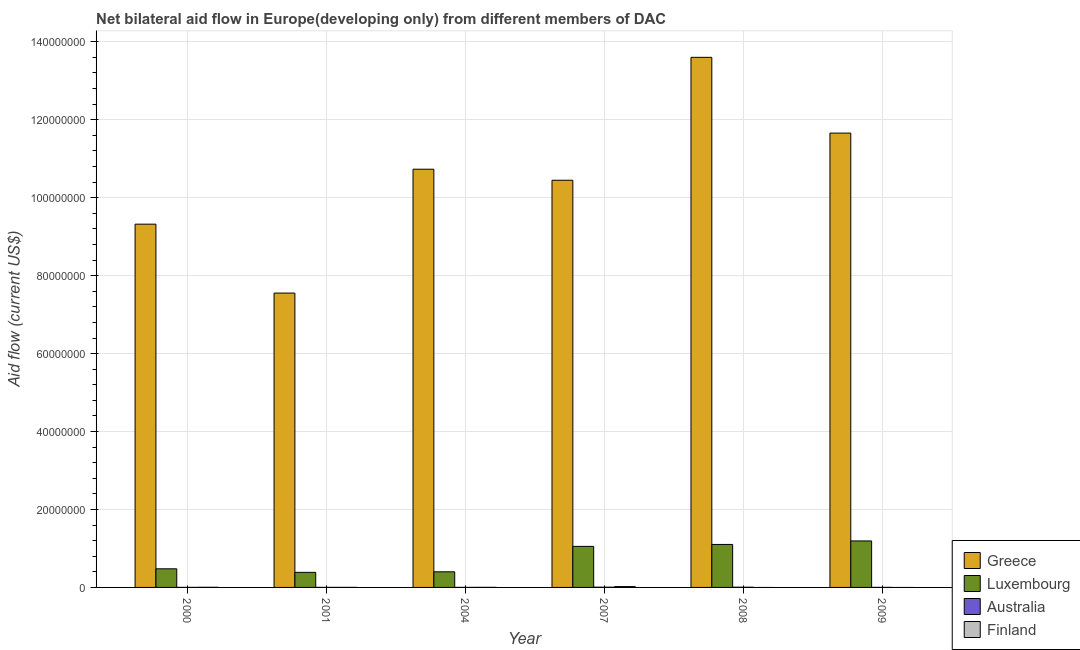How many groups of bars are there?
Make the answer very short. 6. Are the number of bars per tick equal to the number of legend labels?
Make the answer very short. No. How many bars are there on the 2nd tick from the left?
Give a very brief answer. 4. In how many cases, is the number of bars for a given year not equal to the number of legend labels?
Your answer should be very brief. 2. What is the amount of aid given by greece in 2004?
Give a very brief answer. 1.07e+08. Across all years, what is the maximum amount of aid given by luxembourg?
Provide a short and direct response. 1.19e+07. Across all years, what is the minimum amount of aid given by australia?
Make the answer very short. 10000. What is the total amount of aid given by finland in the graph?
Offer a terse response. 2.70e+05. What is the difference between the amount of aid given by australia in 2000 and that in 2008?
Your answer should be very brief. -4.00e+04. What is the difference between the amount of aid given by finland in 2008 and the amount of aid given by australia in 2000?
Ensure brevity in your answer.  -3.00e+04. What is the average amount of aid given by luxembourg per year?
Provide a succinct answer. 7.69e+06. In the year 2001, what is the difference between the amount of aid given by luxembourg and amount of aid given by finland?
Give a very brief answer. 0. What is the difference between the highest and the second highest amount of aid given by luxembourg?
Make the answer very short. 9.00e+05. What is the difference between the highest and the lowest amount of aid given by greece?
Your answer should be very brief. 6.05e+07. How many years are there in the graph?
Give a very brief answer. 6. What is the difference between two consecutive major ticks on the Y-axis?
Your answer should be compact. 2.00e+07. Are the values on the major ticks of Y-axis written in scientific E-notation?
Provide a succinct answer. No. Does the graph contain grids?
Offer a terse response. Yes. What is the title of the graph?
Offer a very short reply. Net bilateral aid flow in Europe(developing only) from different members of DAC. Does "UNHCR" appear as one of the legend labels in the graph?
Your answer should be very brief. No. What is the label or title of the X-axis?
Your answer should be compact. Year. What is the label or title of the Y-axis?
Your response must be concise. Aid flow (current US$). What is the Aid flow (current US$) of Greece in 2000?
Make the answer very short. 9.32e+07. What is the Aid flow (current US$) of Luxembourg in 2000?
Your response must be concise. 4.78e+06. What is the Aid flow (current US$) of Finland in 2000?
Offer a terse response. 3.00e+04. What is the Aid flow (current US$) in Greece in 2001?
Offer a terse response. 7.55e+07. What is the Aid flow (current US$) of Luxembourg in 2001?
Your response must be concise. 3.87e+06. What is the Aid flow (current US$) of Australia in 2001?
Your response must be concise. 10000. What is the Aid flow (current US$) of Finland in 2001?
Your response must be concise. 10000. What is the Aid flow (current US$) of Greece in 2004?
Your response must be concise. 1.07e+08. What is the Aid flow (current US$) in Luxembourg in 2004?
Provide a short and direct response. 4.01e+06. What is the Aid flow (current US$) in Australia in 2004?
Give a very brief answer. 10000. What is the Aid flow (current US$) of Greece in 2007?
Your answer should be very brief. 1.04e+08. What is the Aid flow (current US$) of Luxembourg in 2007?
Offer a terse response. 1.05e+07. What is the Aid flow (current US$) of Australia in 2007?
Make the answer very short. 6.00e+04. What is the Aid flow (current US$) of Finland in 2007?
Make the answer very short. 2.10e+05. What is the Aid flow (current US$) of Greece in 2008?
Provide a short and direct response. 1.36e+08. What is the Aid flow (current US$) of Luxembourg in 2008?
Provide a short and direct response. 1.10e+07. What is the Aid flow (current US$) in Finland in 2008?
Ensure brevity in your answer.  0. What is the Aid flow (current US$) of Greece in 2009?
Your response must be concise. 1.17e+08. What is the Aid flow (current US$) of Luxembourg in 2009?
Your response must be concise. 1.19e+07. Across all years, what is the maximum Aid flow (current US$) of Greece?
Offer a very short reply. 1.36e+08. Across all years, what is the maximum Aid flow (current US$) of Luxembourg?
Your response must be concise. 1.19e+07. Across all years, what is the maximum Aid flow (current US$) of Finland?
Make the answer very short. 2.10e+05. Across all years, what is the minimum Aid flow (current US$) of Greece?
Your answer should be very brief. 7.55e+07. Across all years, what is the minimum Aid flow (current US$) of Luxembourg?
Provide a succinct answer. 3.87e+06. Across all years, what is the minimum Aid flow (current US$) of Finland?
Provide a succinct answer. 0. What is the total Aid flow (current US$) in Greece in the graph?
Your answer should be compact. 6.33e+08. What is the total Aid flow (current US$) of Luxembourg in the graph?
Make the answer very short. 4.62e+07. What is the total Aid flow (current US$) of Australia in the graph?
Your answer should be very brief. 1.50e+05. What is the total Aid flow (current US$) in Finland in the graph?
Provide a short and direct response. 2.70e+05. What is the difference between the Aid flow (current US$) of Greece in 2000 and that in 2001?
Your answer should be compact. 1.77e+07. What is the difference between the Aid flow (current US$) in Luxembourg in 2000 and that in 2001?
Provide a succinct answer. 9.10e+05. What is the difference between the Aid flow (current US$) of Finland in 2000 and that in 2001?
Make the answer very short. 2.00e+04. What is the difference between the Aid flow (current US$) in Greece in 2000 and that in 2004?
Your answer should be very brief. -1.41e+07. What is the difference between the Aid flow (current US$) of Luxembourg in 2000 and that in 2004?
Offer a terse response. 7.70e+05. What is the difference between the Aid flow (current US$) of Australia in 2000 and that in 2004?
Offer a very short reply. 0. What is the difference between the Aid flow (current US$) in Greece in 2000 and that in 2007?
Offer a very short reply. -1.13e+07. What is the difference between the Aid flow (current US$) in Luxembourg in 2000 and that in 2007?
Your answer should be compact. -5.75e+06. What is the difference between the Aid flow (current US$) in Greece in 2000 and that in 2008?
Keep it short and to the point. -4.28e+07. What is the difference between the Aid flow (current US$) of Luxembourg in 2000 and that in 2008?
Your response must be concise. -6.25e+06. What is the difference between the Aid flow (current US$) of Australia in 2000 and that in 2008?
Your answer should be very brief. -4.00e+04. What is the difference between the Aid flow (current US$) of Greece in 2000 and that in 2009?
Provide a succinct answer. -2.34e+07. What is the difference between the Aid flow (current US$) of Luxembourg in 2000 and that in 2009?
Offer a very short reply. -7.15e+06. What is the difference between the Aid flow (current US$) in Australia in 2000 and that in 2009?
Offer a very short reply. 0. What is the difference between the Aid flow (current US$) of Greece in 2001 and that in 2004?
Make the answer very short. -3.18e+07. What is the difference between the Aid flow (current US$) in Luxembourg in 2001 and that in 2004?
Provide a succinct answer. -1.40e+05. What is the difference between the Aid flow (current US$) of Australia in 2001 and that in 2004?
Ensure brevity in your answer.  0. What is the difference between the Aid flow (current US$) of Greece in 2001 and that in 2007?
Your answer should be very brief. -2.90e+07. What is the difference between the Aid flow (current US$) of Luxembourg in 2001 and that in 2007?
Provide a succinct answer. -6.66e+06. What is the difference between the Aid flow (current US$) of Finland in 2001 and that in 2007?
Offer a very short reply. -2.00e+05. What is the difference between the Aid flow (current US$) in Greece in 2001 and that in 2008?
Your answer should be very brief. -6.05e+07. What is the difference between the Aid flow (current US$) of Luxembourg in 2001 and that in 2008?
Make the answer very short. -7.16e+06. What is the difference between the Aid flow (current US$) in Australia in 2001 and that in 2008?
Give a very brief answer. -4.00e+04. What is the difference between the Aid flow (current US$) of Greece in 2001 and that in 2009?
Offer a very short reply. -4.10e+07. What is the difference between the Aid flow (current US$) of Luxembourg in 2001 and that in 2009?
Your answer should be compact. -8.06e+06. What is the difference between the Aid flow (current US$) of Australia in 2001 and that in 2009?
Make the answer very short. 0. What is the difference between the Aid flow (current US$) of Greece in 2004 and that in 2007?
Give a very brief answer. 2.83e+06. What is the difference between the Aid flow (current US$) of Luxembourg in 2004 and that in 2007?
Your response must be concise. -6.52e+06. What is the difference between the Aid flow (current US$) in Finland in 2004 and that in 2007?
Keep it short and to the point. -1.90e+05. What is the difference between the Aid flow (current US$) in Greece in 2004 and that in 2008?
Your response must be concise. -2.87e+07. What is the difference between the Aid flow (current US$) of Luxembourg in 2004 and that in 2008?
Provide a short and direct response. -7.02e+06. What is the difference between the Aid flow (current US$) in Australia in 2004 and that in 2008?
Your response must be concise. -4.00e+04. What is the difference between the Aid flow (current US$) of Greece in 2004 and that in 2009?
Ensure brevity in your answer.  -9.27e+06. What is the difference between the Aid flow (current US$) in Luxembourg in 2004 and that in 2009?
Make the answer very short. -7.92e+06. What is the difference between the Aid flow (current US$) of Greece in 2007 and that in 2008?
Offer a terse response. -3.15e+07. What is the difference between the Aid flow (current US$) in Luxembourg in 2007 and that in 2008?
Ensure brevity in your answer.  -5.00e+05. What is the difference between the Aid flow (current US$) in Greece in 2007 and that in 2009?
Your answer should be very brief. -1.21e+07. What is the difference between the Aid flow (current US$) of Luxembourg in 2007 and that in 2009?
Offer a very short reply. -1.40e+06. What is the difference between the Aid flow (current US$) of Greece in 2008 and that in 2009?
Ensure brevity in your answer.  1.94e+07. What is the difference between the Aid flow (current US$) in Luxembourg in 2008 and that in 2009?
Your answer should be compact. -9.00e+05. What is the difference between the Aid flow (current US$) of Australia in 2008 and that in 2009?
Ensure brevity in your answer.  4.00e+04. What is the difference between the Aid flow (current US$) of Greece in 2000 and the Aid flow (current US$) of Luxembourg in 2001?
Keep it short and to the point. 8.93e+07. What is the difference between the Aid flow (current US$) in Greece in 2000 and the Aid flow (current US$) in Australia in 2001?
Make the answer very short. 9.32e+07. What is the difference between the Aid flow (current US$) of Greece in 2000 and the Aid flow (current US$) of Finland in 2001?
Provide a succinct answer. 9.32e+07. What is the difference between the Aid flow (current US$) in Luxembourg in 2000 and the Aid flow (current US$) in Australia in 2001?
Ensure brevity in your answer.  4.77e+06. What is the difference between the Aid flow (current US$) in Luxembourg in 2000 and the Aid flow (current US$) in Finland in 2001?
Give a very brief answer. 4.77e+06. What is the difference between the Aid flow (current US$) of Greece in 2000 and the Aid flow (current US$) of Luxembourg in 2004?
Your answer should be compact. 8.92e+07. What is the difference between the Aid flow (current US$) of Greece in 2000 and the Aid flow (current US$) of Australia in 2004?
Ensure brevity in your answer.  9.32e+07. What is the difference between the Aid flow (current US$) in Greece in 2000 and the Aid flow (current US$) in Finland in 2004?
Make the answer very short. 9.32e+07. What is the difference between the Aid flow (current US$) of Luxembourg in 2000 and the Aid flow (current US$) of Australia in 2004?
Your answer should be compact. 4.77e+06. What is the difference between the Aid flow (current US$) of Luxembourg in 2000 and the Aid flow (current US$) of Finland in 2004?
Offer a terse response. 4.76e+06. What is the difference between the Aid flow (current US$) of Greece in 2000 and the Aid flow (current US$) of Luxembourg in 2007?
Your answer should be very brief. 8.27e+07. What is the difference between the Aid flow (current US$) of Greece in 2000 and the Aid flow (current US$) of Australia in 2007?
Provide a short and direct response. 9.32e+07. What is the difference between the Aid flow (current US$) in Greece in 2000 and the Aid flow (current US$) in Finland in 2007?
Give a very brief answer. 9.30e+07. What is the difference between the Aid flow (current US$) in Luxembourg in 2000 and the Aid flow (current US$) in Australia in 2007?
Make the answer very short. 4.72e+06. What is the difference between the Aid flow (current US$) in Luxembourg in 2000 and the Aid flow (current US$) in Finland in 2007?
Make the answer very short. 4.57e+06. What is the difference between the Aid flow (current US$) of Australia in 2000 and the Aid flow (current US$) of Finland in 2007?
Ensure brevity in your answer.  -2.00e+05. What is the difference between the Aid flow (current US$) of Greece in 2000 and the Aid flow (current US$) of Luxembourg in 2008?
Keep it short and to the point. 8.22e+07. What is the difference between the Aid flow (current US$) in Greece in 2000 and the Aid flow (current US$) in Australia in 2008?
Your answer should be compact. 9.32e+07. What is the difference between the Aid flow (current US$) in Luxembourg in 2000 and the Aid flow (current US$) in Australia in 2008?
Give a very brief answer. 4.73e+06. What is the difference between the Aid flow (current US$) in Greece in 2000 and the Aid flow (current US$) in Luxembourg in 2009?
Your answer should be compact. 8.13e+07. What is the difference between the Aid flow (current US$) of Greece in 2000 and the Aid flow (current US$) of Australia in 2009?
Make the answer very short. 9.32e+07. What is the difference between the Aid flow (current US$) in Luxembourg in 2000 and the Aid flow (current US$) in Australia in 2009?
Make the answer very short. 4.77e+06. What is the difference between the Aid flow (current US$) of Greece in 2001 and the Aid flow (current US$) of Luxembourg in 2004?
Provide a succinct answer. 7.15e+07. What is the difference between the Aid flow (current US$) in Greece in 2001 and the Aid flow (current US$) in Australia in 2004?
Ensure brevity in your answer.  7.55e+07. What is the difference between the Aid flow (current US$) of Greece in 2001 and the Aid flow (current US$) of Finland in 2004?
Offer a very short reply. 7.55e+07. What is the difference between the Aid flow (current US$) of Luxembourg in 2001 and the Aid flow (current US$) of Australia in 2004?
Provide a short and direct response. 3.86e+06. What is the difference between the Aid flow (current US$) of Luxembourg in 2001 and the Aid flow (current US$) of Finland in 2004?
Offer a terse response. 3.85e+06. What is the difference between the Aid flow (current US$) of Greece in 2001 and the Aid flow (current US$) of Luxembourg in 2007?
Give a very brief answer. 6.50e+07. What is the difference between the Aid flow (current US$) in Greece in 2001 and the Aid flow (current US$) in Australia in 2007?
Provide a short and direct response. 7.55e+07. What is the difference between the Aid flow (current US$) in Greece in 2001 and the Aid flow (current US$) in Finland in 2007?
Offer a terse response. 7.53e+07. What is the difference between the Aid flow (current US$) in Luxembourg in 2001 and the Aid flow (current US$) in Australia in 2007?
Provide a succinct answer. 3.81e+06. What is the difference between the Aid flow (current US$) of Luxembourg in 2001 and the Aid flow (current US$) of Finland in 2007?
Your response must be concise. 3.66e+06. What is the difference between the Aid flow (current US$) in Greece in 2001 and the Aid flow (current US$) in Luxembourg in 2008?
Your response must be concise. 6.45e+07. What is the difference between the Aid flow (current US$) in Greece in 2001 and the Aid flow (current US$) in Australia in 2008?
Ensure brevity in your answer.  7.55e+07. What is the difference between the Aid flow (current US$) of Luxembourg in 2001 and the Aid flow (current US$) of Australia in 2008?
Offer a terse response. 3.82e+06. What is the difference between the Aid flow (current US$) in Greece in 2001 and the Aid flow (current US$) in Luxembourg in 2009?
Make the answer very short. 6.36e+07. What is the difference between the Aid flow (current US$) of Greece in 2001 and the Aid flow (current US$) of Australia in 2009?
Provide a succinct answer. 7.55e+07. What is the difference between the Aid flow (current US$) of Luxembourg in 2001 and the Aid flow (current US$) of Australia in 2009?
Give a very brief answer. 3.86e+06. What is the difference between the Aid flow (current US$) of Greece in 2004 and the Aid flow (current US$) of Luxembourg in 2007?
Your response must be concise. 9.68e+07. What is the difference between the Aid flow (current US$) in Greece in 2004 and the Aid flow (current US$) in Australia in 2007?
Offer a very short reply. 1.07e+08. What is the difference between the Aid flow (current US$) of Greece in 2004 and the Aid flow (current US$) of Finland in 2007?
Your answer should be very brief. 1.07e+08. What is the difference between the Aid flow (current US$) of Luxembourg in 2004 and the Aid flow (current US$) of Australia in 2007?
Provide a short and direct response. 3.95e+06. What is the difference between the Aid flow (current US$) in Luxembourg in 2004 and the Aid flow (current US$) in Finland in 2007?
Provide a succinct answer. 3.80e+06. What is the difference between the Aid flow (current US$) in Greece in 2004 and the Aid flow (current US$) in Luxembourg in 2008?
Your answer should be very brief. 9.63e+07. What is the difference between the Aid flow (current US$) in Greece in 2004 and the Aid flow (current US$) in Australia in 2008?
Your answer should be compact. 1.07e+08. What is the difference between the Aid flow (current US$) of Luxembourg in 2004 and the Aid flow (current US$) of Australia in 2008?
Give a very brief answer. 3.96e+06. What is the difference between the Aid flow (current US$) in Greece in 2004 and the Aid flow (current US$) in Luxembourg in 2009?
Your response must be concise. 9.54e+07. What is the difference between the Aid flow (current US$) of Greece in 2004 and the Aid flow (current US$) of Australia in 2009?
Provide a short and direct response. 1.07e+08. What is the difference between the Aid flow (current US$) of Greece in 2007 and the Aid flow (current US$) of Luxembourg in 2008?
Your response must be concise. 9.34e+07. What is the difference between the Aid flow (current US$) in Greece in 2007 and the Aid flow (current US$) in Australia in 2008?
Provide a succinct answer. 1.04e+08. What is the difference between the Aid flow (current US$) of Luxembourg in 2007 and the Aid flow (current US$) of Australia in 2008?
Provide a short and direct response. 1.05e+07. What is the difference between the Aid flow (current US$) of Greece in 2007 and the Aid flow (current US$) of Luxembourg in 2009?
Offer a very short reply. 9.26e+07. What is the difference between the Aid flow (current US$) in Greece in 2007 and the Aid flow (current US$) in Australia in 2009?
Offer a very short reply. 1.04e+08. What is the difference between the Aid flow (current US$) of Luxembourg in 2007 and the Aid flow (current US$) of Australia in 2009?
Provide a short and direct response. 1.05e+07. What is the difference between the Aid flow (current US$) in Greece in 2008 and the Aid flow (current US$) in Luxembourg in 2009?
Keep it short and to the point. 1.24e+08. What is the difference between the Aid flow (current US$) of Greece in 2008 and the Aid flow (current US$) of Australia in 2009?
Your answer should be very brief. 1.36e+08. What is the difference between the Aid flow (current US$) of Luxembourg in 2008 and the Aid flow (current US$) of Australia in 2009?
Provide a succinct answer. 1.10e+07. What is the average Aid flow (current US$) of Greece per year?
Offer a terse response. 1.06e+08. What is the average Aid flow (current US$) of Luxembourg per year?
Provide a short and direct response. 7.69e+06. What is the average Aid flow (current US$) in Australia per year?
Ensure brevity in your answer.  2.50e+04. What is the average Aid flow (current US$) in Finland per year?
Provide a short and direct response. 4.50e+04. In the year 2000, what is the difference between the Aid flow (current US$) in Greece and Aid flow (current US$) in Luxembourg?
Offer a terse response. 8.84e+07. In the year 2000, what is the difference between the Aid flow (current US$) of Greece and Aid flow (current US$) of Australia?
Provide a short and direct response. 9.32e+07. In the year 2000, what is the difference between the Aid flow (current US$) in Greece and Aid flow (current US$) in Finland?
Your answer should be compact. 9.32e+07. In the year 2000, what is the difference between the Aid flow (current US$) in Luxembourg and Aid flow (current US$) in Australia?
Offer a very short reply. 4.77e+06. In the year 2000, what is the difference between the Aid flow (current US$) in Luxembourg and Aid flow (current US$) in Finland?
Make the answer very short. 4.75e+06. In the year 2000, what is the difference between the Aid flow (current US$) of Australia and Aid flow (current US$) of Finland?
Give a very brief answer. -2.00e+04. In the year 2001, what is the difference between the Aid flow (current US$) of Greece and Aid flow (current US$) of Luxembourg?
Your answer should be compact. 7.17e+07. In the year 2001, what is the difference between the Aid flow (current US$) of Greece and Aid flow (current US$) of Australia?
Offer a very short reply. 7.55e+07. In the year 2001, what is the difference between the Aid flow (current US$) in Greece and Aid flow (current US$) in Finland?
Give a very brief answer. 7.55e+07. In the year 2001, what is the difference between the Aid flow (current US$) in Luxembourg and Aid flow (current US$) in Australia?
Offer a terse response. 3.86e+06. In the year 2001, what is the difference between the Aid flow (current US$) in Luxembourg and Aid flow (current US$) in Finland?
Your answer should be very brief. 3.86e+06. In the year 2004, what is the difference between the Aid flow (current US$) of Greece and Aid flow (current US$) of Luxembourg?
Provide a succinct answer. 1.03e+08. In the year 2004, what is the difference between the Aid flow (current US$) in Greece and Aid flow (current US$) in Australia?
Ensure brevity in your answer.  1.07e+08. In the year 2004, what is the difference between the Aid flow (current US$) in Greece and Aid flow (current US$) in Finland?
Offer a very short reply. 1.07e+08. In the year 2004, what is the difference between the Aid flow (current US$) of Luxembourg and Aid flow (current US$) of Finland?
Your answer should be very brief. 3.99e+06. In the year 2004, what is the difference between the Aid flow (current US$) in Australia and Aid flow (current US$) in Finland?
Offer a very short reply. -10000. In the year 2007, what is the difference between the Aid flow (current US$) in Greece and Aid flow (current US$) in Luxembourg?
Make the answer very short. 9.40e+07. In the year 2007, what is the difference between the Aid flow (current US$) of Greece and Aid flow (current US$) of Australia?
Your answer should be very brief. 1.04e+08. In the year 2007, what is the difference between the Aid flow (current US$) in Greece and Aid flow (current US$) in Finland?
Offer a terse response. 1.04e+08. In the year 2007, what is the difference between the Aid flow (current US$) of Luxembourg and Aid flow (current US$) of Australia?
Give a very brief answer. 1.05e+07. In the year 2007, what is the difference between the Aid flow (current US$) in Luxembourg and Aid flow (current US$) in Finland?
Your response must be concise. 1.03e+07. In the year 2008, what is the difference between the Aid flow (current US$) of Greece and Aid flow (current US$) of Luxembourg?
Your answer should be compact. 1.25e+08. In the year 2008, what is the difference between the Aid flow (current US$) in Greece and Aid flow (current US$) in Australia?
Provide a short and direct response. 1.36e+08. In the year 2008, what is the difference between the Aid flow (current US$) of Luxembourg and Aid flow (current US$) of Australia?
Make the answer very short. 1.10e+07. In the year 2009, what is the difference between the Aid flow (current US$) in Greece and Aid flow (current US$) in Luxembourg?
Provide a succinct answer. 1.05e+08. In the year 2009, what is the difference between the Aid flow (current US$) of Greece and Aid flow (current US$) of Australia?
Offer a terse response. 1.17e+08. In the year 2009, what is the difference between the Aid flow (current US$) of Luxembourg and Aid flow (current US$) of Australia?
Make the answer very short. 1.19e+07. What is the ratio of the Aid flow (current US$) of Greece in 2000 to that in 2001?
Make the answer very short. 1.23. What is the ratio of the Aid flow (current US$) of Luxembourg in 2000 to that in 2001?
Make the answer very short. 1.24. What is the ratio of the Aid flow (current US$) of Australia in 2000 to that in 2001?
Give a very brief answer. 1. What is the ratio of the Aid flow (current US$) in Finland in 2000 to that in 2001?
Offer a very short reply. 3. What is the ratio of the Aid flow (current US$) in Greece in 2000 to that in 2004?
Provide a short and direct response. 0.87. What is the ratio of the Aid flow (current US$) of Luxembourg in 2000 to that in 2004?
Your answer should be compact. 1.19. What is the ratio of the Aid flow (current US$) of Greece in 2000 to that in 2007?
Offer a terse response. 0.89. What is the ratio of the Aid flow (current US$) in Luxembourg in 2000 to that in 2007?
Offer a terse response. 0.45. What is the ratio of the Aid flow (current US$) in Australia in 2000 to that in 2007?
Your answer should be compact. 0.17. What is the ratio of the Aid flow (current US$) in Finland in 2000 to that in 2007?
Your answer should be compact. 0.14. What is the ratio of the Aid flow (current US$) in Greece in 2000 to that in 2008?
Offer a very short reply. 0.69. What is the ratio of the Aid flow (current US$) of Luxembourg in 2000 to that in 2008?
Your response must be concise. 0.43. What is the ratio of the Aid flow (current US$) of Greece in 2000 to that in 2009?
Your answer should be very brief. 0.8. What is the ratio of the Aid flow (current US$) in Luxembourg in 2000 to that in 2009?
Offer a terse response. 0.4. What is the ratio of the Aid flow (current US$) of Greece in 2001 to that in 2004?
Give a very brief answer. 0.7. What is the ratio of the Aid flow (current US$) in Luxembourg in 2001 to that in 2004?
Your answer should be very brief. 0.97. What is the ratio of the Aid flow (current US$) in Greece in 2001 to that in 2007?
Provide a succinct answer. 0.72. What is the ratio of the Aid flow (current US$) of Luxembourg in 2001 to that in 2007?
Offer a very short reply. 0.37. What is the ratio of the Aid flow (current US$) of Australia in 2001 to that in 2007?
Your response must be concise. 0.17. What is the ratio of the Aid flow (current US$) in Finland in 2001 to that in 2007?
Your answer should be compact. 0.05. What is the ratio of the Aid flow (current US$) in Greece in 2001 to that in 2008?
Give a very brief answer. 0.56. What is the ratio of the Aid flow (current US$) of Luxembourg in 2001 to that in 2008?
Your response must be concise. 0.35. What is the ratio of the Aid flow (current US$) in Greece in 2001 to that in 2009?
Your answer should be very brief. 0.65. What is the ratio of the Aid flow (current US$) in Luxembourg in 2001 to that in 2009?
Your response must be concise. 0.32. What is the ratio of the Aid flow (current US$) in Australia in 2001 to that in 2009?
Your answer should be compact. 1. What is the ratio of the Aid flow (current US$) of Greece in 2004 to that in 2007?
Make the answer very short. 1.03. What is the ratio of the Aid flow (current US$) of Luxembourg in 2004 to that in 2007?
Give a very brief answer. 0.38. What is the ratio of the Aid flow (current US$) in Finland in 2004 to that in 2007?
Your answer should be very brief. 0.1. What is the ratio of the Aid flow (current US$) of Greece in 2004 to that in 2008?
Offer a very short reply. 0.79. What is the ratio of the Aid flow (current US$) of Luxembourg in 2004 to that in 2008?
Make the answer very short. 0.36. What is the ratio of the Aid flow (current US$) in Australia in 2004 to that in 2008?
Offer a very short reply. 0.2. What is the ratio of the Aid flow (current US$) of Greece in 2004 to that in 2009?
Your answer should be compact. 0.92. What is the ratio of the Aid flow (current US$) in Luxembourg in 2004 to that in 2009?
Your answer should be compact. 0.34. What is the ratio of the Aid flow (current US$) in Australia in 2004 to that in 2009?
Ensure brevity in your answer.  1. What is the ratio of the Aid flow (current US$) of Greece in 2007 to that in 2008?
Ensure brevity in your answer.  0.77. What is the ratio of the Aid flow (current US$) of Luxembourg in 2007 to that in 2008?
Make the answer very short. 0.95. What is the ratio of the Aid flow (current US$) of Greece in 2007 to that in 2009?
Ensure brevity in your answer.  0.9. What is the ratio of the Aid flow (current US$) in Luxembourg in 2007 to that in 2009?
Your answer should be very brief. 0.88. What is the ratio of the Aid flow (current US$) of Greece in 2008 to that in 2009?
Give a very brief answer. 1.17. What is the ratio of the Aid flow (current US$) in Luxembourg in 2008 to that in 2009?
Make the answer very short. 0.92. What is the ratio of the Aid flow (current US$) in Australia in 2008 to that in 2009?
Keep it short and to the point. 5. What is the difference between the highest and the second highest Aid flow (current US$) of Greece?
Provide a succinct answer. 1.94e+07. What is the difference between the highest and the second highest Aid flow (current US$) of Australia?
Give a very brief answer. 10000. What is the difference between the highest and the lowest Aid flow (current US$) in Greece?
Provide a succinct answer. 6.05e+07. What is the difference between the highest and the lowest Aid flow (current US$) in Luxembourg?
Provide a succinct answer. 8.06e+06. What is the difference between the highest and the lowest Aid flow (current US$) of Australia?
Offer a terse response. 5.00e+04. 